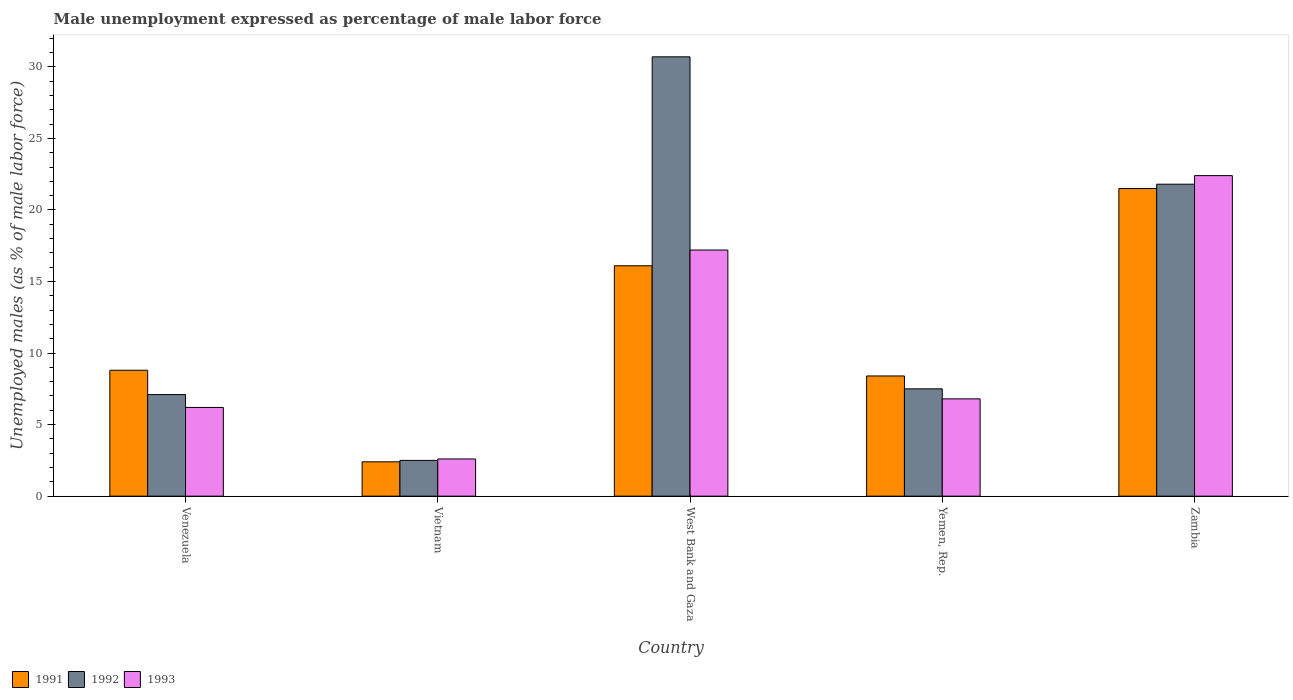How many bars are there on the 3rd tick from the right?
Offer a very short reply. 3. What is the label of the 2nd group of bars from the left?
Provide a succinct answer. Vietnam. What is the unemployment in males in in 1992 in Zambia?
Your answer should be compact. 21.8. Across all countries, what is the maximum unemployment in males in in 1991?
Your response must be concise. 21.5. Across all countries, what is the minimum unemployment in males in in 1992?
Offer a terse response. 2.5. In which country was the unemployment in males in in 1991 maximum?
Provide a succinct answer. Zambia. In which country was the unemployment in males in in 1993 minimum?
Make the answer very short. Vietnam. What is the total unemployment in males in in 1991 in the graph?
Your answer should be very brief. 57.2. What is the difference between the unemployment in males in in 1993 in Vietnam and that in West Bank and Gaza?
Give a very brief answer. -14.6. What is the difference between the unemployment in males in in 1993 in Yemen, Rep. and the unemployment in males in in 1991 in Vietnam?
Offer a terse response. 4.4. What is the average unemployment in males in in 1993 per country?
Your answer should be compact. 11.04. What is the difference between the unemployment in males in of/in 1992 and unemployment in males in of/in 1991 in Venezuela?
Ensure brevity in your answer.  -1.7. What is the ratio of the unemployment in males in in 1992 in Vietnam to that in Zambia?
Provide a short and direct response. 0.11. Is the difference between the unemployment in males in in 1992 in Venezuela and West Bank and Gaza greater than the difference between the unemployment in males in in 1991 in Venezuela and West Bank and Gaza?
Your answer should be compact. No. What is the difference between the highest and the second highest unemployment in males in in 1992?
Ensure brevity in your answer.  -8.9. What is the difference between the highest and the lowest unemployment in males in in 1993?
Make the answer very short. 19.8. In how many countries, is the unemployment in males in in 1992 greater than the average unemployment in males in in 1992 taken over all countries?
Your answer should be compact. 2. Is the sum of the unemployment in males in in 1991 in Vietnam and Yemen, Rep. greater than the maximum unemployment in males in in 1993 across all countries?
Keep it short and to the point. No. Are all the bars in the graph horizontal?
Your response must be concise. No. What is the difference between two consecutive major ticks on the Y-axis?
Offer a terse response. 5. Are the values on the major ticks of Y-axis written in scientific E-notation?
Provide a succinct answer. No. Does the graph contain any zero values?
Your response must be concise. No. Where does the legend appear in the graph?
Your answer should be compact. Bottom left. How many legend labels are there?
Offer a terse response. 3. How are the legend labels stacked?
Ensure brevity in your answer.  Horizontal. What is the title of the graph?
Offer a very short reply. Male unemployment expressed as percentage of male labor force. Does "1964" appear as one of the legend labels in the graph?
Provide a short and direct response. No. What is the label or title of the Y-axis?
Your response must be concise. Unemployed males (as % of male labor force). What is the Unemployed males (as % of male labor force) of 1991 in Venezuela?
Ensure brevity in your answer.  8.8. What is the Unemployed males (as % of male labor force) of 1992 in Venezuela?
Your answer should be very brief. 7.1. What is the Unemployed males (as % of male labor force) of 1993 in Venezuela?
Offer a very short reply. 6.2. What is the Unemployed males (as % of male labor force) in 1991 in Vietnam?
Your response must be concise. 2.4. What is the Unemployed males (as % of male labor force) in 1993 in Vietnam?
Your answer should be compact. 2.6. What is the Unemployed males (as % of male labor force) of 1991 in West Bank and Gaza?
Your response must be concise. 16.1. What is the Unemployed males (as % of male labor force) of 1992 in West Bank and Gaza?
Offer a terse response. 30.7. What is the Unemployed males (as % of male labor force) in 1993 in West Bank and Gaza?
Make the answer very short. 17.2. What is the Unemployed males (as % of male labor force) of 1991 in Yemen, Rep.?
Make the answer very short. 8.4. What is the Unemployed males (as % of male labor force) in 1992 in Yemen, Rep.?
Make the answer very short. 7.5. What is the Unemployed males (as % of male labor force) of 1993 in Yemen, Rep.?
Make the answer very short. 6.8. What is the Unemployed males (as % of male labor force) in 1991 in Zambia?
Make the answer very short. 21.5. What is the Unemployed males (as % of male labor force) in 1992 in Zambia?
Make the answer very short. 21.8. What is the Unemployed males (as % of male labor force) in 1993 in Zambia?
Offer a very short reply. 22.4. Across all countries, what is the maximum Unemployed males (as % of male labor force) in 1992?
Offer a terse response. 30.7. Across all countries, what is the maximum Unemployed males (as % of male labor force) in 1993?
Ensure brevity in your answer.  22.4. Across all countries, what is the minimum Unemployed males (as % of male labor force) in 1991?
Offer a terse response. 2.4. Across all countries, what is the minimum Unemployed males (as % of male labor force) in 1992?
Provide a succinct answer. 2.5. Across all countries, what is the minimum Unemployed males (as % of male labor force) in 1993?
Offer a terse response. 2.6. What is the total Unemployed males (as % of male labor force) in 1991 in the graph?
Keep it short and to the point. 57.2. What is the total Unemployed males (as % of male labor force) in 1992 in the graph?
Your answer should be compact. 69.6. What is the total Unemployed males (as % of male labor force) of 1993 in the graph?
Offer a very short reply. 55.2. What is the difference between the Unemployed males (as % of male labor force) in 1991 in Venezuela and that in Vietnam?
Make the answer very short. 6.4. What is the difference between the Unemployed males (as % of male labor force) of 1993 in Venezuela and that in Vietnam?
Give a very brief answer. 3.6. What is the difference between the Unemployed males (as % of male labor force) in 1991 in Venezuela and that in West Bank and Gaza?
Your answer should be compact. -7.3. What is the difference between the Unemployed males (as % of male labor force) of 1992 in Venezuela and that in West Bank and Gaza?
Your response must be concise. -23.6. What is the difference between the Unemployed males (as % of male labor force) in 1991 in Venezuela and that in Yemen, Rep.?
Give a very brief answer. 0.4. What is the difference between the Unemployed males (as % of male labor force) of 1993 in Venezuela and that in Yemen, Rep.?
Make the answer very short. -0.6. What is the difference between the Unemployed males (as % of male labor force) in 1991 in Venezuela and that in Zambia?
Ensure brevity in your answer.  -12.7. What is the difference between the Unemployed males (as % of male labor force) in 1992 in Venezuela and that in Zambia?
Give a very brief answer. -14.7. What is the difference between the Unemployed males (as % of male labor force) of 1993 in Venezuela and that in Zambia?
Give a very brief answer. -16.2. What is the difference between the Unemployed males (as % of male labor force) of 1991 in Vietnam and that in West Bank and Gaza?
Provide a short and direct response. -13.7. What is the difference between the Unemployed males (as % of male labor force) of 1992 in Vietnam and that in West Bank and Gaza?
Offer a very short reply. -28.2. What is the difference between the Unemployed males (as % of male labor force) of 1993 in Vietnam and that in West Bank and Gaza?
Your answer should be compact. -14.6. What is the difference between the Unemployed males (as % of male labor force) of 1991 in Vietnam and that in Yemen, Rep.?
Your answer should be compact. -6. What is the difference between the Unemployed males (as % of male labor force) of 1991 in Vietnam and that in Zambia?
Provide a short and direct response. -19.1. What is the difference between the Unemployed males (as % of male labor force) of 1992 in Vietnam and that in Zambia?
Your answer should be very brief. -19.3. What is the difference between the Unemployed males (as % of male labor force) in 1993 in Vietnam and that in Zambia?
Offer a terse response. -19.8. What is the difference between the Unemployed males (as % of male labor force) in 1992 in West Bank and Gaza and that in Yemen, Rep.?
Provide a short and direct response. 23.2. What is the difference between the Unemployed males (as % of male labor force) of 1993 in West Bank and Gaza and that in Yemen, Rep.?
Offer a very short reply. 10.4. What is the difference between the Unemployed males (as % of male labor force) of 1992 in West Bank and Gaza and that in Zambia?
Give a very brief answer. 8.9. What is the difference between the Unemployed males (as % of male labor force) in 1991 in Yemen, Rep. and that in Zambia?
Offer a terse response. -13.1. What is the difference between the Unemployed males (as % of male labor force) in 1992 in Yemen, Rep. and that in Zambia?
Keep it short and to the point. -14.3. What is the difference between the Unemployed males (as % of male labor force) in 1993 in Yemen, Rep. and that in Zambia?
Offer a terse response. -15.6. What is the difference between the Unemployed males (as % of male labor force) in 1991 in Venezuela and the Unemployed males (as % of male labor force) in 1992 in Vietnam?
Offer a terse response. 6.3. What is the difference between the Unemployed males (as % of male labor force) in 1991 in Venezuela and the Unemployed males (as % of male labor force) in 1993 in Vietnam?
Keep it short and to the point. 6.2. What is the difference between the Unemployed males (as % of male labor force) of 1992 in Venezuela and the Unemployed males (as % of male labor force) of 1993 in Vietnam?
Give a very brief answer. 4.5. What is the difference between the Unemployed males (as % of male labor force) of 1991 in Venezuela and the Unemployed males (as % of male labor force) of 1992 in West Bank and Gaza?
Your response must be concise. -21.9. What is the difference between the Unemployed males (as % of male labor force) in 1992 in Venezuela and the Unemployed males (as % of male labor force) in 1993 in West Bank and Gaza?
Ensure brevity in your answer.  -10.1. What is the difference between the Unemployed males (as % of male labor force) in 1991 in Venezuela and the Unemployed males (as % of male labor force) in 1993 in Yemen, Rep.?
Offer a terse response. 2. What is the difference between the Unemployed males (as % of male labor force) of 1992 in Venezuela and the Unemployed males (as % of male labor force) of 1993 in Yemen, Rep.?
Make the answer very short. 0.3. What is the difference between the Unemployed males (as % of male labor force) of 1991 in Venezuela and the Unemployed males (as % of male labor force) of 1993 in Zambia?
Provide a short and direct response. -13.6. What is the difference between the Unemployed males (as % of male labor force) in 1992 in Venezuela and the Unemployed males (as % of male labor force) in 1993 in Zambia?
Give a very brief answer. -15.3. What is the difference between the Unemployed males (as % of male labor force) of 1991 in Vietnam and the Unemployed males (as % of male labor force) of 1992 in West Bank and Gaza?
Ensure brevity in your answer.  -28.3. What is the difference between the Unemployed males (as % of male labor force) in 1991 in Vietnam and the Unemployed males (as % of male labor force) in 1993 in West Bank and Gaza?
Make the answer very short. -14.8. What is the difference between the Unemployed males (as % of male labor force) of 1992 in Vietnam and the Unemployed males (as % of male labor force) of 1993 in West Bank and Gaza?
Your response must be concise. -14.7. What is the difference between the Unemployed males (as % of male labor force) in 1991 in Vietnam and the Unemployed males (as % of male labor force) in 1993 in Yemen, Rep.?
Make the answer very short. -4.4. What is the difference between the Unemployed males (as % of male labor force) of 1992 in Vietnam and the Unemployed males (as % of male labor force) of 1993 in Yemen, Rep.?
Your response must be concise. -4.3. What is the difference between the Unemployed males (as % of male labor force) in 1991 in Vietnam and the Unemployed males (as % of male labor force) in 1992 in Zambia?
Offer a terse response. -19.4. What is the difference between the Unemployed males (as % of male labor force) in 1992 in Vietnam and the Unemployed males (as % of male labor force) in 1993 in Zambia?
Your answer should be very brief. -19.9. What is the difference between the Unemployed males (as % of male labor force) of 1991 in West Bank and Gaza and the Unemployed males (as % of male labor force) of 1992 in Yemen, Rep.?
Your answer should be compact. 8.6. What is the difference between the Unemployed males (as % of male labor force) of 1991 in West Bank and Gaza and the Unemployed males (as % of male labor force) of 1993 in Yemen, Rep.?
Your answer should be compact. 9.3. What is the difference between the Unemployed males (as % of male labor force) in 1992 in West Bank and Gaza and the Unemployed males (as % of male labor force) in 1993 in Yemen, Rep.?
Ensure brevity in your answer.  23.9. What is the difference between the Unemployed males (as % of male labor force) of 1991 in West Bank and Gaza and the Unemployed males (as % of male labor force) of 1993 in Zambia?
Provide a succinct answer. -6.3. What is the difference between the Unemployed males (as % of male labor force) of 1992 in Yemen, Rep. and the Unemployed males (as % of male labor force) of 1993 in Zambia?
Your answer should be compact. -14.9. What is the average Unemployed males (as % of male labor force) in 1991 per country?
Keep it short and to the point. 11.44. What is the average Unemployed males (as % of male labor force) of 1992 per country?
Offer a very short reply. 13.92. What is the average Unemployed males (as % of male labor force) of 1993 per country?
Offer a terse response. 11.04. What is the difference between the Unemployed males (as % of male labor force) of 1991 and Unemployed males (as % of male labor force) of 1992 in Venezuela?
Make the answer very short. 1.7. What is the difference between the Unemployed males (as % of male labor force) of 1991 and Unemployed males (as % of male labor force) of 1993 in Venezuela?
Ensure brevity in your answer.  2.6. What is the difference between the Unemployed males (as % of male labor force) in 1992 and Unemployed males (as % of male labor force) in 1993 in Venezuela?
Offer a terse response. 0.9. What is the difference between the Unemployed males (as % of male labor force) of 1991 and Unemployed males (as % of male labor force) of 1992 in Vietnam?
Ensure brevity in your answer.  -0.1. What is the difference between the Unemployed males (as % of male labor force) in 1991 and Unemployed males (as % of male labor force) in 1992 in West Bank and Gaza?
Your answer should be compact. -14.6. What is the difference between the Unemployed males (as % of male labor force) of 1992 and Unemployed males (as % of male labor force) of 1993 in West Bank and Gaza?
Give a very brief answer. 13.5. What is the difference between the Unemployed males (as % of male labor force) in 1991 and Unemployed males (as % of male labor force) in 1993 in Yemen, Rep.?
Your answer should be very brief. 1.6. What is the difference between the Unemployed males (as % of male labor force) of 1991 and Unemployed males (as % of male labor force) of 1992 in Zambia?
Provide a short and direct response. -0.3. What is the difference between the Unemployed males (as % of male labor force) in 1992 and Unemployed males (as % of male labor force) in 1993 in Zambia?
Keep it short and to the point. -0.6. What is the ratio of the Unemployed males (as % of male labor force) in 1991 in Venezuela to that in Vietnam?
Give a very brief answer. 3.67. What is the ratio of the Unemployed males (as % of male labor force) in 1992 in Venezuela to that in Vietnam?
Give a very brief answer. 2.84. What is the ratio of the Unemployed males (as % of male labor force) of 1993 in Venezuela to that in Vietnam?
Make the answer very short. 2.38. What is the ratio of the Unemployed males (as % of male labor force) of 1991 in Venezuela to that in West Bank and Gaza?
Provide a succinct answer. 0.55. What is the ratio of the Unemployed males (as % of male labor force) of 1992 in Venezuela to that in West Bank and Gaza?
Provide a short and direct response. 0.23. What is the ratio of the Unemployed males (as % of male labor force) in 1993 in Venezuela to that in West Bank and Gaza?
Offer a terse response. 0.36. What is the ratio of the Unemployed males (as % of male labor force) of 1991 in Venezuela to that in Yemen, Rep.?
Ensure brevity in your answer.  1.05. What is the ratio of the Unemployed males (as % of male labor force) in 1992 in Venezuela to that in Yemen, Rep.?
Your answer should be very brief. 0.95. What is the ratio of the Unemployed males (as % of male labor force) in 1993 in Venezuela to that in Yemen, Rep.?
Offer a very short reply. 0.91. What is the ratio of the Unemployed males (as % of male labor force) in 1991 in Venezuela to that in Zambia?
Ensure brevity in your answer.  0.41. What is the ratio of the Unemployed males (as % of male labor force) of 1992 in Venezuela to that in Zambia?
Offer a terse response. 0.33. What is the ratio of the Unemployed males (as % of male labor force) in 1993 in Venezuela to that in Zambia?
Your answer should be compact. 0.28. What is the ratio of the Unemployed males (as % of male labor force) in 1991 in Vietnam to that in West Bank and Gaza?
Offer a very short reply. 0.15. What is the ratio of the Unemployed males (as % of male labor force) in 1992 in Vietnam to that in West Bank and Gaza?
Offer a terse response. 0.08. What is the ratio of the Unemployed males (as % of male labor force) of 1993 in Vietnam to that in West Bank and Gaza?
Offer a very short reply. 0.15. What is the ratio of the Unemployed males (as % of male labor force) of 1991 in Vietnam to that in Yemen, Rep.?
Your answer should be compact. 0.29. What is the ratio of the Unemployed males (as % of male labor force) of 1992 in Vietnam to that in Yemen, Rep.?
Provide a short and direct response. 0.33. What is the ratio of the Unemployed males (as % of male labor force) in 1993 in Vietnam to that in Yemen, Rep.?
Ensure brevity in your answer.  0.38. What is the ratio of the Unemployed males (as % of male labor force) of 1991 in Vietnam to that in Zambia?
Offer a terse response. 0.11. What is the ratio of the Unemployed males (as % of male labor force) of 1992 in Vietnam to that in Zambia?
Keep it short and to the point. 0.11. What is the ratio of the Unemployed males (as % of male labor force) of 1993 in Vietnam to that in Zambia?
Make the answer very short. 0.12. What is the ratio of the Unemployed males (as % of male labor force) of 1991 in West Bank and Gaza to that in Yemen, Rep.?
Your response must be concise. 1.92. What is the ratio of the Unemployed males (as % of male labor force) in 1992 in West Bank and Gaza to that in Yemen, Rep.?
Ensure brevity in your answer.  4.09. What is the ratio of the Unemployed males (as % of male labor force) of 1993 in West Bank and Gaza to that in Yemen, Rep.?
Your response must be concise. 2.53. What is the ratio of the Unemployed males (as % of male labor force) in 1991 in West Bank and Gaza to that in Zambia?
Provide a short and direct response. 0.75. What is the ratio of the Unemployed males (as % of male labor force) of 1992 in West Bank and Gaza to that in Zambia?
Your answer should be very brief. 1.41. What is the ratio of the Unemployed males (as % of male labor force) of 1993 in West Bank and Gaza to that in Zambia?
Ensure brevity in your answer.  0.77. What is the ratio of the Unemployed males (as % of male labor force) in 1991 in Yemen, Rep. to that in Zambia?
Your response must be concise. 0.39. What is the ratio of the Unemployed males (as % of male labor force) of 1992 in Yemen, Rep. to that in Zambia?
Make the answer very short. 0.34. What is the ratio of the Unemployed males (as % of male labor force) of 1993 in Yemen, Rep. to that in Zambia?
Your response must be concise. 0.3. What is the difference between the highest and the second highest Unemployed males (as % of male labor force) in 1992?
Your response must be concise. 8.9. What is the difference between the highest and the second highest Unemployed males (as % of male labor force) of 1993?
Ensure brevity in your answer.  5.2. What is the difference between the highest and the lowest Unemployed males (as % of male labor force) of 1992?
Your answer should be compact. 28.2. What is the difference between the highest and the lowest Unemployed males (as % of male labor force) of 1993?
Your answer should be very brief. 19.8. 